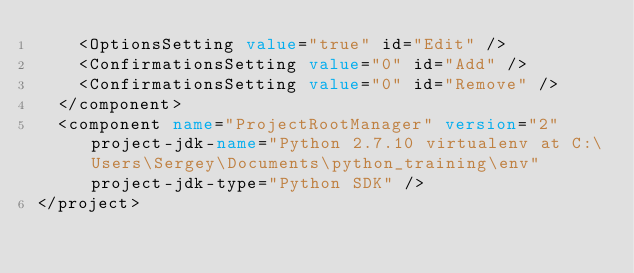Convert code to text. <code><loc_0><loc_0><loc_500><loc_500><_XML_>    <OptionsSetting value="true" id="Edit" />
    <ConfirmationsSetting value="0" id="Add" />
    <ConfirmationsSetting value="0" id="Remove" />
  </component>
  <component name="ProjectRootManager" version="2" project-jdk-name="Python 2.7.10 virtualenv at C:\Users\Sergey\Documents\python_training\env" project-jdk-type="Python SDK" />
</project></code> 